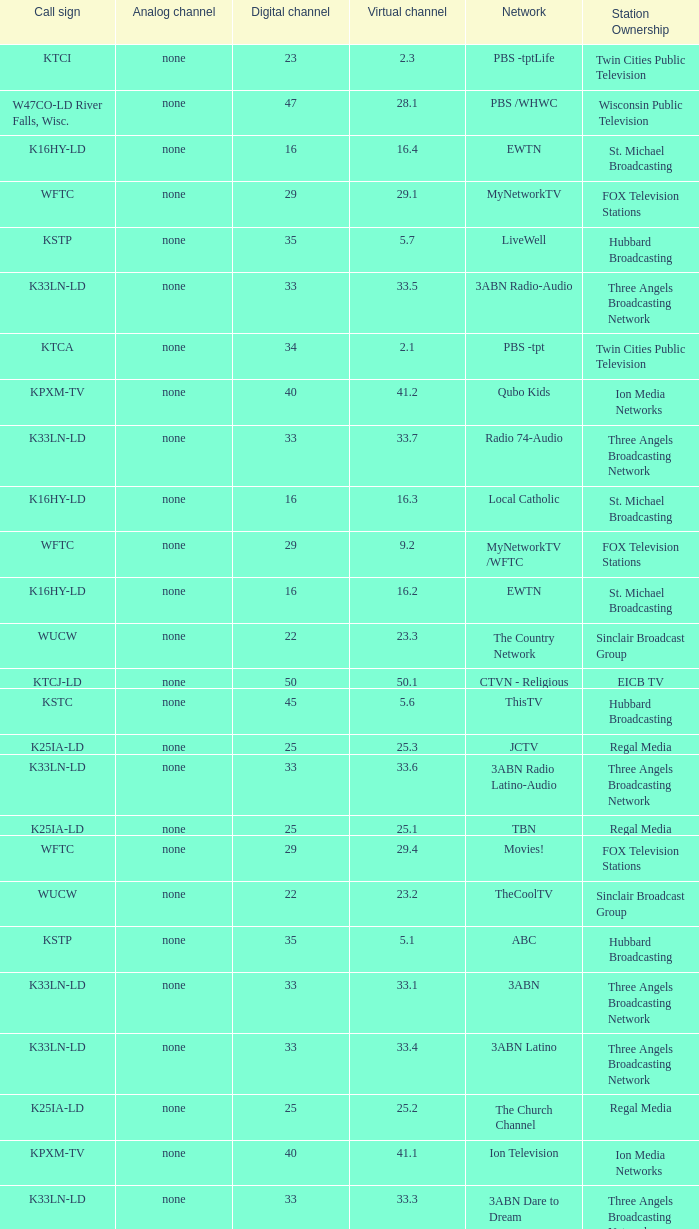Network of nbc is what digital channel? 11.0. Parse the full table. {'header': ['Call sign', 'Analog channel', 'Digital channel', 'Virtual channel', 'Network', 'Station Ownership'], 'rows': [['KTCI', 'none', '23', '2.3', 'PBS -tptLife', 'Twin Cities Public Television'], ['W47CO-LD River Falls, Wisc.', 'none', '47', '28.1', 'PBS /WHWC', 'Wisconsin Public Television'], ['K16HY-LD', 'none', '16', '16.4', 'EWTN', 'St. Michael Broadcasting'], ['WFTC', 'none', '29', '29.1', 'MyNetworkTV', 'FOX Television Stations'], ['KSTP', 'none', '35', '5.7', 'LiveWell', 'Hubbard Broadcasting'], ['K33LN-LD', 'none', '33', '33.5', '3ABN Radio-Audio', 'Three Angels Broadcasting Network'], ['KTCA', 'none', '34', '2.1', 'PBS -tpt', 'Twin Cities Public Television'], ['KPXM-TV', 'none', '40', '41.2', 'Qubo Kids', 'Ion Media Networks'], ['K33LN-LD', 'none', '33', '33.7', 'Radio 74-Audio', 'Three Angels Broadcasting Network'], ['K16HY-LD', 'none', '16', '16.3', 'Local Catholic', 'St. Michael Broadcasting'], ['WFTC', 'none', '29', '9.2', 'MyNetworkTV /WFTC', 'FOX Television Stations'], ['K16HY-LD', 'none', '16', '16.2', 'EWTN', 'St. Michael Broadcasting'], ['WUCW', 'none', '22', '23.3', 'The Country Network', 'Sinclair Broadcast Group'], ['KTCJ-LD', 'none', '50', '50.1', 'CTVN - Religious', 'EICB TV'], ['KSTC', 'none', '45', '5.6', 'ThisTV', 'Hubbard Broadcasting'], ['K25IA-LD', 'none', '25', '25.3', 'JCTV', 'Regal Media'], ['K33LN-LD', 'none', '33', '33.6', '3ABN Radio Latino-Audio', 'Three Angels Broadcasting Network'], ['K25IA-LD', 'none', '25', '25.1', 'TBN', 'Regal Media'], ['WFTC', 'none', '29', '29.4', 'Movies!', 'FOX Television Stations'], ['WUCW', 'none', '22', '23.2', 'TheCoolTV', 'Sinclair Broadcast Group'], ['KSTP', 'none', '35', '5.1', 'ABC', 'Hubbard Broadcasting'], ['K33LN-LD', 'none', '33', '33.1', '3ABN', 'Three Angels Broadcasting Network'], ['K33LN-LD', 'none', '33', '33.4', '3ABN Latino', 'Three Angels Broadcasting Network'], ['K25IA-LD', 'none', '25', '25.2', 'The Church Channel', 'Regal Media'], ['KPXM-TV', 'none', '40', '41.1', 'Ion Television', 'Ion Media Networks'], ['K33LN-LD', 'none', '33', '33.3', '3ABN Dare to Dream', 'Three Angels Broadcasting Network'], ['KPXM-TV', 'none', '40', '41.3', 'Ion Life', 'Ion Media Networks'], ['W47CO-LD River Falls, Wisc.', 'none', '47', '28.2', 'PBS -WISC/WHWC', 'Wisconsin Public Television'], ['K33LN-LD', 'none', '33', '33.2', '3ABN Proclaim!', 'Three Angels Broadcasting Network'], ['KMSP', 'none', '9', '9.3', 'The Local AccuWeather Channel', 'FOX Television Stations'], ['K25IA-LD', 'none', '25', '25.5', 'TBN Enlace', 'Regal Media'], ['KARE', 'none', '11', '11.1', 'NBC', 'Gannett Company'], ['KTCI', 'none', '23', '23.7~*', 'PBS -tptMN', 'Twin Cities Public Television'], ['WUMN-LP', '13', 'none', 'N/A', 'Univision', 'Silver Point Capital'], ['KTCA', 'none', '34', '2.2', 'PBS -tptMN', 'Twin Cities Public Television'], ['WUCW', 'none', '22', '23.1', 'CW', 'Sinclair Broadcast Group'], ['WDMI-LD', 'none', '31', '62.1', 'Daystar', 'Word of God Fellowship'], ['KTCA', 'none', '34', '2.4', 'PBS -tptWx', 'Twin Cities Public Television'], ['KMSP', 'none', '9', '9.1', 'Fox', 'FOX Television Stations'], ['W47CO-LD River Falls, Wisc.', 'none', '47', '28.3', 'PBS -Create/WHWC', 'Wisconsin Public Television'], ['K43HB-LD', 'none', '43', '43.1', 'HSN', 'Ventana Television'], ['WCCO', 'none', '32', '4.1', 'CBS', 'CBS Television Stations'], ['K16HY-LD', 'none', '16', '16.1', 'Local Catholic-Text', 'St. Michael Broadcasting'], ['KARE', 'none', '11', '11.2', 'WeatherNation TV', 'Gannett Company'], ['KSTC', 'none', '45', '5.3', 'MeTV', 'Hubbard Broadcasting'], ['WFTC', 'none', '29', '29.3', 'Bounce TV', 'FOX Television Stations'], ['K25IA-LD', 'none', '25', '25.4', 'Smile Of A Child', 'Regal Media'], ['KHVM-LD', 'none', '48', '48.1', 'GCN - Religious', 'EICB TV'], ['KSTC', 'none', '45', '5.2', 'Independent', 'Hubbard Broadcasting'], ['KMSP', 'none', '9', '29.2', 'MyNetworkTV /WFTC', 'FOX Television Stations'], ['KSTC', 'none', '45', '5.4', 'AntennaTV', 'Hubbard Broadcasting'], ['K19BG-LD St. Cloud/Buffalo', 'silent', '19CP', '19', 'RTV', 'Luken Communications'], ['K16HY-LD', 'none', '16', '16.5', 'EWTN', 'St. Michael Broadcasting']]} 